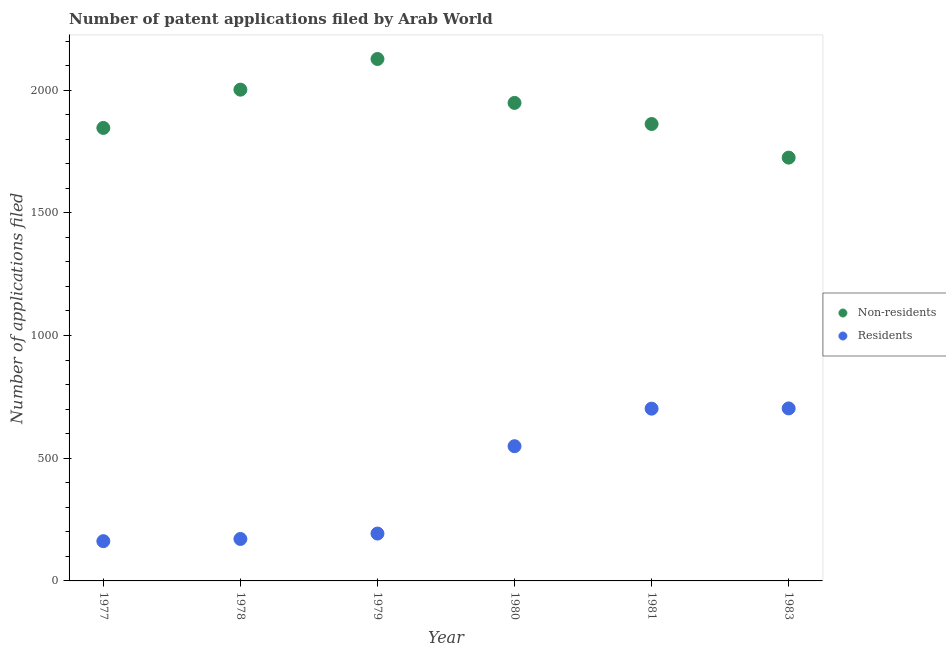What is the number of patent applications by non residents in 1980?
Your answer should be compact. 1948. Across all years, what is the maximum number of patent applications by residents?
Ensure brevity in your answer.  703. Across all years, what is the minimum number of patent applications by residents?
Provide a succinct answer. 162. What is the total number of patent applications by residents in the graph?
Make the answer very short. 2480. What is the difference between the number of patent applications by residents in 1978 and that in 1981?
Provide a short and direct response. -531. What is the difference between the number of patent applications by residents in 1979 and the number of patent applications by non residents in 1978?
Keep it short and to the point. -1809. What is the average number of patent applications by residents per year?
Your response must be concise. 413.33. In the year 1979, what is the difference between the number of patent applications by non residents and number of patent applications by residents?
Offer a very short reply. 1934. In how many years, is the number of patent applications by residents greater than 1700?
Ensure brevity in your answer.  0. What is the ratio of the number of patent applications by non residents in 1978 to that in 1979?
Offer a very short reply. 0.94. Is the difference between the number of patent applications by non residents in 1977 and 1983 greater than the difference between the number of patent applications by residents in 1977 and 1983?
Ensure brevity in your answer.  Yes. What is the difference between the highest and the lowest number of patent applications by residents?
Provide a short and direct response. 541. Is the sum of the number of patent applications by residents in 1977 and 1978 greater than the maximum number of patent applications by non residents across all years?
Your response must be concise. No. Is the number of patent applications by residents strictly greater than the number of patent applications by non residents over the years?
Your response must be concise. No. Is the number of patent applications by non residents strictly less than the number of patent applications by residents over the years?
Your answer should be compact. No. How many dotlines are there?
Provide a short and direct response. 2. How many years are there in the graph?
Keep it short and to the point. 6. Does the graph contain grids?
Your answer should be very brief. No. How many legend labels are there?
Offer a terse response. 2. How are the legend labels stacked?
Provide a succinct answer. Vertical. What is the title of the graph?
Your answer should be very brief. Number of patent applications filed by Arab World. Does "Primary education" appear as one of the legend labels in the graph?
Provide a short and direct response. No. What is the label or title of the Y-axis?
Ensure brevity in your answer.  Number of applications filed. What is the Number of applications filed of Non-residents in 1977?
Give a very brief answer. 1846. What is the Number of applications filed in Residents in 1977?
Your response must be concise. 162. What is the Number of applications filed of Non-residents in 1978?
Give a very brief answer. 2002. What is the Number of applications filed of Residents in 1978?
Provide a succinct answer. 171. What is the Number of applications filed of Non-residents in 1979?
Keep it short and to the point. 2127. What is the Number of applications filed of Residents in 1979?
Give a very brief answer. 193. What is the Number of applications filed of Non-residents in 1980?
Offer a terse response. 1948. What is the Number of applications filed of Residents in 1980?
Make the answer very short. 549. What is the Number of applications filed of Non-residents in 1981?
Offer a terse response. 1862. What is the Number of applications filed of Residents in 1981?
Keep it short and to the point. 702. What is the Number of applications filed of Non-residents in 1983?
Offer a terse response. 1725. What is the Number of applications filed of Residents in 1983?
Ensure brevity in your answer.  703. Across all years, what is the maximum Number of applications filed of Non-residents?
Keep it short and to the point. 2127. Across all years, what is the maximum Number of applications filed of Residents?
Your answer should be very brief. 703. Across all years, what is the minimum Number of applications filed of Non-residents?
Your answer should be compact. 1725. Across all years, what is the minimum Number of applications filed in Residents?
Provide a short and direct response. 162. What is the total Number of applications filed in Non-residents in the graph?
Offer a terse response. 1.15e+04. What is the total Number of applications filed of Residents in the graph?
Keep it short and to the point. 2480. What is the difference between the Number of applications filed of Non-residents in 1977 and that in 1978?
Ensure brevity in your answer.  -156. What is the difference between the Number of applications filed of Non-residents in 1977 and that in 1979?
Your answer should be very brief. -281. What is the difference between the Number of applications filed of Residents in 1977 and that in 1979?
Offer a very short reply. -31. What is the difference between the Number of applications filed in Non-residents in 1977 and that in 1980?
Your answer should be compact. -102. What is the difference between the Number of applications filed of Residents in 1977 and that in 1980?
Make the answer very short. -387. What is the difference between the Number of applications filed in Residents in 1977 and that in 1981?
Your answer should be very brief. -540. What is the difference between the Number of applications filed of Non-residents in 1977 and that in 1983?
Give a very brief answer. 121. What is the difference between the Number of applications filed in Residents in 1977 and that in 1983?
Keep it short and to the point. -541. What is the difference between the Number of applications filed in Non-residents in 1978 and that in 1979?
Keep it short and to the point. -125. What is the difference between the Number of applications filed of Residents in 1978 and that in 1979?
Offer a very short reply. -22. What is the difference between the Number of applications filed in Non-residents in 1978 and that in 1980?
Provide a short and direct response. 54. What is the difference between the Number of applications filed of Residents in 1978 and that in 1980?
Your response must be concise. -378. What is the difference between the Number of applications filed in Non-residents in 1978 and that in 1981?
Make the answer very short. 140. What is the difference between the Number of applications filed in Residents in 1978 and that in 1981?
Keep it short and to the point. -531. What is the difference between the Number of applications filed of Non-residents in 1978 and that in 1983?
Your answer should be compact. 277. What is the difference between the Number of applications filed of Residents in 1978 and that in 1983?
Your answer should be very brief. -532. What is the difference between the Number of applications filed of Non-residents in 1979 and that in 1980?
Ensure brevity in your answer.  179. What is the difference between the Number of applications filed in Residents in 1979 and that in 1980?
Give a very brief answer. -356. What is the difference between the Number of applications filed of Non-residents in 1979 and that in 1981?
Provide a succinct answer. 265. What is the difference between the Number of applications filed in Residents in 1979 and that in 1981?
Provide a succinct answer. -509. What is the difference between the Number of applications filed in Non-residents in 1979 and that in 1983?
Offer a very short reply. 402. What is the difference between the Number of applications filed of Residents in 1979 and that in 1983?
Give a very brief answer. -510. What is the difference between the Number of applications filed in Non-residents in 1980 and that in 1981?
Ensure brevity in your answer.  86. What is the difference between the Number of applications filed of Residents in 1980 and that in 1981?
Your answer should be compact. -153. What is the difference between the Number of applications filed of Non-residents in 1980 and that in 1983?
Make the answer very short. 223. What is the difference between the Number of applications filed in Residents in 1980 and that in 1983?
Your response must be concise. -154. What is the difference between the Number of applications filed in Non-residents in 1981 and that in 1983?
Your answer should be very brief. 137. What is the difference between the Number of applications filed of Non-residents in 1977 and the Number of applications filed of Residents in 1978?
Ensure brevity in your answer.  1675. What is the difference between the Number of applications filed of Non-residents in 1977 and the Number of applications filed of Residents in 1979?
Your answer should be very brief. 1653. What is the difference between the Number of applications filed in Non-residents in 1977 and the Number of applications filed in Residents in 1980?
Your response must be concise. 1297. What is the difference between the Number of applications filed of Non-residents in 1977 and the Number of applications filed of Residents in 1981?
Provide a short and direct response. 1144. What is the difference between the Number of applications filed in Non-residents in 1977 and the Number of applications filed in Residents in 1983?
Offer a very short reply. 1143. What is the difference between the Number of applications filed of Non-residents in 1978 and the Number of applications filed of Residents in 1979?
Offer a very short reply. 1809. What is the difference between the Number of applications filed in Non-residents in 1978 and the Number of applications filed in Residents in 1980?
Provide a succinct answer. 1453. What is the difference between the Number of applications filed of Non-residents in 1978 and the Number of applications filed of Residents in 1981?
Make the answer very short. 1300. What is the difference between the Number of applications filed in Non-residents in 1978 and the Number of applications filed in Residents in 1983?
Your response must be concise. 1299. What is the difference between the Number of applications filed in Non-residents in 1979 and the Number of applications filed in Residents in 1980?
Your answer should be compact. 1578. What is the difference between the Number of applications filed in Non-residents in 1979 and the Number of applications filed in Residents in 1981?
Your answer should be compact. 1425. What is the difference between the Number of applications filed of Non-residents in 1979 and the Number of applications filed of Residents in 1983?
Keep it short and to the point. 1424. What is the difference between the Number of applications filed of Non-residents in 1980 and the Number of applications filed of Residents in 1981?
Offer a terse response. 1246. What is the difference between the Number of applications filed in Non-residents in 1980 and the Number of applications filed in Residents in 1983?
Offer a terse response. 1245. What is the difference between the Number of applications filed in Non-residents in 1981 and the Number of applications filed in Residents in 1983?
Keep it short and to the point. 1159. What is the average Number of applications filed in Non-residents per year?
Make the answer very short. 1918.33. What is the average Number of applications filed in Residents per year?
Give a very brief answer. 413.33. In the year 1977, what is the difference between the Number of applications filed of Non-residents and Number of applications filed of Residents?
Ensure brevity in your answer.  1684. In the year 1978, what is the difference between the Number of applications filed in Non-residents and Number of applications filed in Residents?
Keep it short and to the point. 1831. In the year 1979, what is the difference between the Number of applications filed of Non-residents and Number of applications filed of Residents?
Offer a terse response. 1934. In the year 1980, what is the difference between the Number of applications filed in Non-residents and Number of applications filed in Residents?
Ensure brevity in your answer.  1399. In the year 1981, what is the difference between the Number of applications filed of Non-residents and Number of applications filed of Residents?
Provide a succinct answer. 1160. In the year 1983, what is the difference between the Number of applications filed in Non-residents and Number of applications filed in Residents?
Provide a short and direct response. 1022. What is the ratio of the Number of applications filed of Non-residents in 1977 to that in 1978?
Your answer should be very brief. 0.92. What is the ratio of the Number of applications filed in Residents in 1977 to that in 1978?
Give a very brief answer. 0.95. What is the ratio of the Number of applications filed in Non-residents in 1977 to that in 1979?
Offer a terse response. 0.87. What is the ratio of the Number of applications filed of Residents in 1977 to that in 1979?
Your response must be concise. 0.84. What is the ratio of the Number of applications filed in Non-residents in 1977 to that in 1980?
Make the answer very short. 0.95. What is the ratio of the Number of applications filed in Residents in 1977 to that in 1980?
Offer a terse response. 0.3. What is the ratio of the Number of applications filed of Residents in 1977 to that in 1981?
Offer a very short reply. 0.23. What is the ratio of the Number of applications filed in Non-residents in 1977 to that in 1983?
Provide a short and direct response. 1.07. What is the ratio of the Number of applications filed in Residents in 1977 to that in 1983?
Your answer should be very brief. 0.23. What is the ratio of the Number of applications filed of Non-residents in 1978 to that in 1979?
Your response must be concise. 0.94. What is the ratio of the Number of applications filed in Residents in 1978 to that in 1979?
Offer a very short reply. 0.89. What is the ratio of the Number of applications filed of Non-residents in 1978 to that in 1980?
Your answer should be very brief. 1.03. What is the ratio of the Number of applications filed of Residents in 1978 to that in 1980?
Make the answer very short. 0.31. What is the ratio of the Number of applications filed in Non-residents in 1978 to that in 1981?
Keep it short and to the point. 1.08. What is the ratio of the Number of applications filed in Residents in 1978 to that in 1981?
Your answer should be very brief. 0.24. What is the ratio of the Number of applications filed in Non-residents in 1978 to that in 1983?
Provide a succinct answer. 1.16. What is the ratio of the Number of applications filed in Residents in 1978 to that in 1983?
Provide a succinct answer. 0.24. What is the ratio of the Number of applications filed of Non-residents in 1979 to that in 1980?
Offer a terse response. 1.09. What is the ratio of the Number of applications filed of Residents in 1979 to that in 1980?
Provide a short and direct response. 0.35. What is the ratio of the Number of applications filed in Non-residents in 1979 to that in 1981?
Your response must be concise. 1.14. What is the ratio of the Number of applications filed of Residents in 1979 to that in 1981?
Keep it short and to the point. 0.27. What is the ratio of the Number of applications filed of Non-residents in 1979 to that in 1983?
Keep it short and to the point. 1.23. What is the ratio of the Number of applications filed of Residents in 1979 to that in 1983?
Provide a short and direct response. 0.27. What is the ratio of the Number of applications filed of Non-residents in 1980 to that in 1981?
Offer a terse response. 1.05. What is the ratio of the Number of applications filed in Residents in 1980 to that in 1981?
Make the answer very short. 0.78. What is the ratio of the Number of applications filed in Non-residents in 1980 to that in 1983?
Keep it short and to the point. 1.13. What is the ratio of the Number of applications filed of Residents in 1980 to that in 1983?
Make the answer very short. 0.78. What is the ratio of the Number of applications filed of Non-residents in 1981 to that in 1983?
Give a very brief answer. 1.08. What is the ratio of the Number of applications filed of Residents in 1981 to that in 1983?
Give a very brief answer. 1. What is the difference between the highest and the second highest Number of applications filed of Non-residents?
Provide a short and direct response. 125. What is the difference between the highest and the lowest Number of applications filed of Non-residents?
Offer a terse response. 402. What is the difference between the highest and the lowest Number of applications filed in Residents?
Provide a short and direct response. 541. 